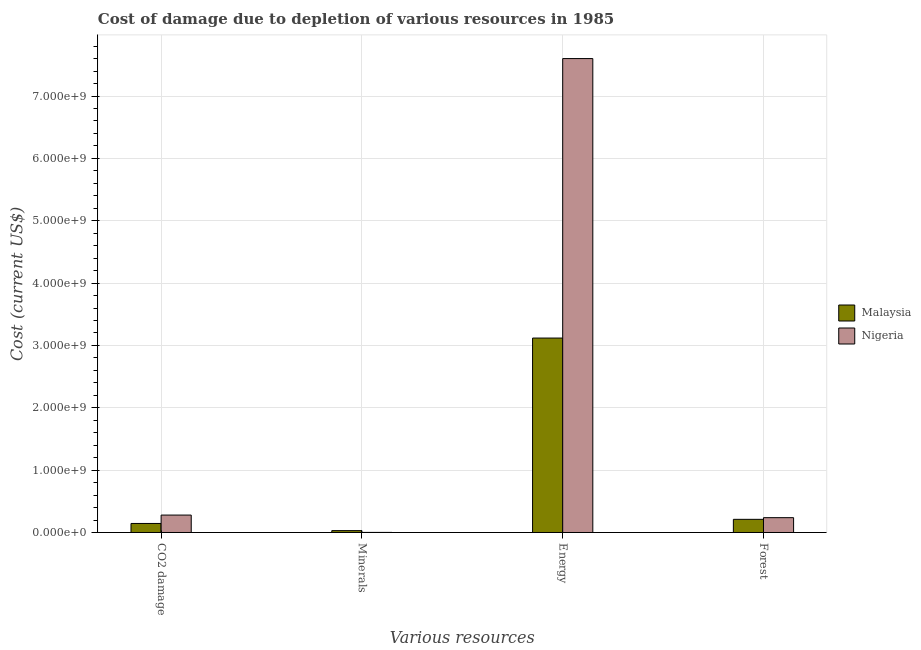How many different coloured bars are there?
Offer a very short reply. 2. How many groups of bars are there?
Ensure brevity in your answer.  4. Are the number of bars on each tick of the X-axis equal?
Your answer should be very brief. Yes. How many bars are there on the 4th tick from the right?
Provide a succinct answer. 2. What is the label of the 4th group of bars from the left?
Make the answer very short. Forest. What is the cost of damage due to depletion of energy in Nigeria?
Provide a short and direct response. 7.60e+09. Across all countries, what is the maximum cost of damage due to depletion of coal?
Offer a very short reply. 2.79e+08. Across all countries, what is the minimum cost of damage due to depletion of forests?
Provide a succinct answer. 2.11e+08. In which country was the cost of damage due to depletion of forests maximum?
Offer a terse response. Nigeria. In which country was the cost of damage due to depletion of minerals minimum?
Your answer should be very brief. Nigeria. What is the total cost of damage due to depletion of coal in the graph?
Give a very brief answer. 4.24e+08. What is the difference between the cost of damage due to depletion of minerals in Malaysia and that in Nigeria?
Offer a very short reply. 2.87e+07. What is the difference between the cost of damage due to depletion of forests in Nigeria and the cost of damage due to depletion of minerals in Malaysia?
Your answer should be compact. 2.08e+08. What is the average cost of damage due to depletion of forests per country?
Offer a very short reply. 2.24e+08. What is the difference between the cost of damage due to depletion of forests and cost of damage due to depletion of energy in Malaysia?
Provide a short and direct response. -2.91e+09. What is the ratio of the cost of damage due to depletion of minerals in Nigeria to that in Malaysia?
Your response must be concise. 0.04. What is the difference between the highest and the second highest cost of damage due to depletion of forests?
Offer a very short reply. 2.68e+07. What is the difference between the highest and the lowest cost of damage due to depletion of minerals?
Provide a short and direct response. 2.87e+07. Is the sum of the cost of damage due to depletion of energy in Nigeria and Malaysia greater than the maximum cost of damage due to depletion of minerals across all countries?
Provide a succinct answer. Yes. What does the 1st bar from the left in Minerals represents?
Ensure brevity in your answer.  Malaysia. What does the 1st bar from the right in Forest represents?
Provide a succinct answer. Nigeria. Are all the bars in the graph horizontal?
Give a very brief answer. No. What is the difference between two consecutive major ticks on the Y-axis?
Make the answer very short. 1.00e+09. Are the values on the major ticks of Y-axis written in scientific E-notation?
Make the answer very short. Yes. Does the graph contain any zero values?
Your answer should be compact. No. Where does the legend appear in the graph?
Offer a terse response. Center right. How many legend labels are there?
Provide a succinct answer. 2. What is the title of the graph?
Offer a terse response. Cost of damage due to depletion of various resources in 1985 . What is the label or title of the X-axis?
Your answer should be compact. Various resources. What is the label or title of the Y-axis?
Provide a short and direct response. Cost (current US$). What is the Cost (current US$) of Malaysia in CO2 damage?
Ensure brevity in your answer.  1.45e+08. What is the Cost (current US$) in Nigeria in CO2 damage?
Your answer should be compact. 2.79e+08. What is the Cost (current US$) in Malaysia in Minerals?
Offer a very short reply. 2.99e+07. What is the Cost (current US$) of Nigeria in Minerals?
Make the answer very short. 1.25e+06. What is the Cost (current US$) in Malaysia in Energy?
Provide a succinct answer. 3.12e+09. What is the Cost (current US$) in Nigeria in Energy?
Your answer should be very brief. 7.60e+09. What is the Cost (current US$) in Malaysia in Forest?
Provide a short and direct response. 2.11e+08. What is the Cost (current US$) in Nigeria in Forest?
Make the answer very short. 2.38e+08. Across all Various resources, what is the maximum Cost (current US$) in Malaysia?
Offer a terse response. 3.12e+09. Across all Various resources, what is the maximum Cost (current US$) in Nigeria?
Your response must be concise. 7.60e+09. Across all Various resources, what is the minimum Cost (current US$) in Malaysia?
Provide a short and direct response. 2.99e+07. Across all Various resources, what is the minimum Cost (current US$) in Nigeria?
Make the answer very short. 1.25e+06. What is the total Cost (current US$) of Malaysia in the graph?
Make the answer very short. 3.50e+09. What is the total Cost (current US$) of Nigeria in the graph?
Your answer should be very brief. 8.12e+09. What is the difference between the Cost (current US$) in Malaysia in CO2 damage and that in Minerals?
Keep it short and to the point. 1.15e+08. What is the difference between the Cost (current US$) in Nigeria in CO2 damage and that in Minerals?
Give a very brief answer. 2.78e+08. What is the difference between the Cost (current US$) in Malaysia in CO2 damage and that in Energy?
Provide a short and direct response. -2.97e+09. What is the difference between the Cost (current US$) in Nigeria in CO2 damage and that in Energy?
Offer a terse response. -7.32e+09. What is the difference between the Cost (current US$) in Malaysia in CO2 damage and that in Forest?
Your answer should be compact. -6.61e+07. What is the difference between the Cost (current US$) of Nigeria in CO2 damage and that in Forest?
Your answer should be compact. 4.16e+07. What is the difference between the Cost (current US$) in Malaysia in Minerals and that in Energy?
Give a very brief answer. -3.09e+09. What is the difference between the Cost (current US$) in Nigeria in Minerals and that in Energy?
Ensure brevity in your answer.  -7.60e+09. What is the difference between the Cost (current US$) in Malaysia in Minerals and that in Forest?
Ensure brevity in your answer.  -1.81e+08. What is the difference between the Cost (current US$) of Nigeria in Minerals and that in Forest?
Keep it short and to the point. -2.36e+08. What is the difference between the Cost (current US$) in Malaysia in Energy and that in Forest?
Give a very brief answer. 2.91e+09. What is the difference between the Cost (current US$) of Nigeria in Energy and that in Forest?
Give a very brief answer. 7.36e+09. What is the difference between the Cost (current US$) of Malaysia in CO2 damage and the Cost (current US$) of Nigeria in Minerals?
Make the answer very short. 1.44e+08. What is the difference between the Cost (current US$) in Malaysia in CO2 damage and the Cost (current US$) in Nigeria in Energy?
Provide a short and direct response. -7.46e+09. What is the difference between the Cost (current US$) of Malaysia in CO2 damage and the Cost (current US$) of Nigeria in Forest?
Offer a very short reply. -9.29e+07. What is the difference between the Cost (current US$) in Malaysia in Minerals and the Cost (current US$) in Nigeria in Energy?
Make the answer very short. -7.57e+09. What is the difference between the Cost (current US$) of Malaysia in Minerals and the Cost (current US$) of Nigeria in Forest?
Your answer should be very brief. -2.08e+08. What is the difference between the Cost (current US$) of Malaysia in Energy and the Cost (current US$) of Nigeria in Forest?
Give a very brief answer. 2.88e+09. What is the average Cost (current US$) in Malaysia per Various resources?
Your answer should be compact. 8.76e+08. What is the average Cost (current US$) of Nigeria per Various resources?
Keep it short and to the point. 2.03e+09. What is the difference between the Cost (current US$) of Malaysia and Cost (current US$) of Nigeria in CO2 damage?
Provide a succinct answer. -1.34e+08. What is the difference between the Cost (current US$) of Malaysia and Cost (current US$) of Nigeria in Minerals?
Your answer should be compact. 2.87e+07. What is the difference between the Cost (current US$) of Malaysia and Cost (current US$) of Nigeria in Energy?
Your answer should be compact. -4.48e+09. What is the difference between the Cost (current US$) of Malaysia and Cost (current US$) of Nigeria in Forest?
Ensure brevity in your answer.  -2.68e+07. What is the ratio of the Cost (current US$) of Malaysia in CO2 damage to that in Minerals?
Offer a very short reply. 4.84. What is the ratio of the Cost (current US$) in Nigeria in CO2 damage to that in Minerals?
Keep it short and to the point. 223.34. What is the ratio of the Cost (current US$) in Malaysia in CO2 damage to that in Energy?
Offer a terse response. 0.05. What is the ratio of the Cost (current US$) in Nigeria in CO2 damage to that in Energy?
Give a very brief answer. 0.04. What is the ratio of the Cost (current US$) of Malaysia in CO2 damage to that in Forest?
Provide a short and direct response. 0.69. What is the ratio of the Cost (current US$) in Nigeria in CO2 damage to that in Forest?
Ensure brevity in your answer.  1.18. What is the ratio of the Cost (current US$) in Malaysia in Minerals to that in Energy?
Your response must be concise. 0.01. What is the ratio of the Cost (current US$) of Malaysia in Minerals to that in Forest?
Keep it short and to the point. 0.14. What is the ratio of the Cost (current US$) of Nigeria in Minerals to that in Forest?
Offer a very short reply. 0.01. What is the ratio of the Cost (current US$) of Malaysia in Energy to that in Forest?
Keep it short and to the point. 14.79. What is the ratio of the Cost (current US$) in Nigeria in Energy to that in Forest?
Provide a short and direct response. 31.98. What is the difference between the highest and the second highest Cost (current US$) in Malaysia?
Your answer should be very brief. 2.91e+09. What is the difference between the highest and the second highest Cost (current US$) of Nigeria?
Offer a very short reply. 7.32e+09. What is the difference between the highest and the lowest Cost (current US$) in Malaysia?
Make the answer very short. 3.09e+09. What is the difference between the highest and the lowest Cost (current US$) of Nigeria?
Provide a succinct answer. 7.60e+09. 